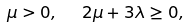Convert formula to latex. <formula><loc_0><loc_0><loc_500><loc_500>\mu > 0 , \ \ 2 \mu + 3 \lambda \geq 0 ,</formula> 